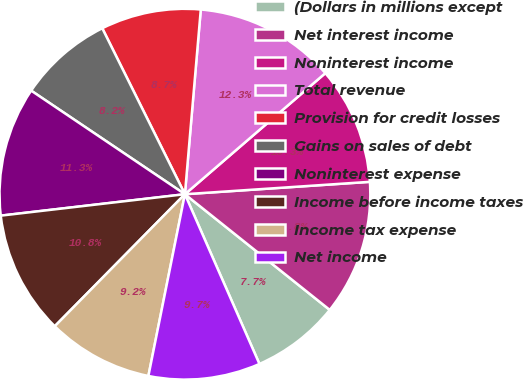Convert chart to OTSL. <chart><loc_0><loc_0><loc_500><loc_500><pie_chart><fcel>(Dollars in millions except<fcel>Net interest income<fcel>Noninterest income<fcel>Total revenue<fcel>Provision for credit losses<fcel>Gains on sales of debt<fcel>Noninterest expense<fcel>Income before income taxes<fcel>Income tax expense<fcel>Net income<nl><fcel>7.69%<fcel>11.79%<fcel>10.26%<fcel>12.31%<fcel>8.72%<fcel>8.21%<fcel>11.28%<fcel>10.77%<fcel>9.23%<fcel>9.74%<nl></chart> 